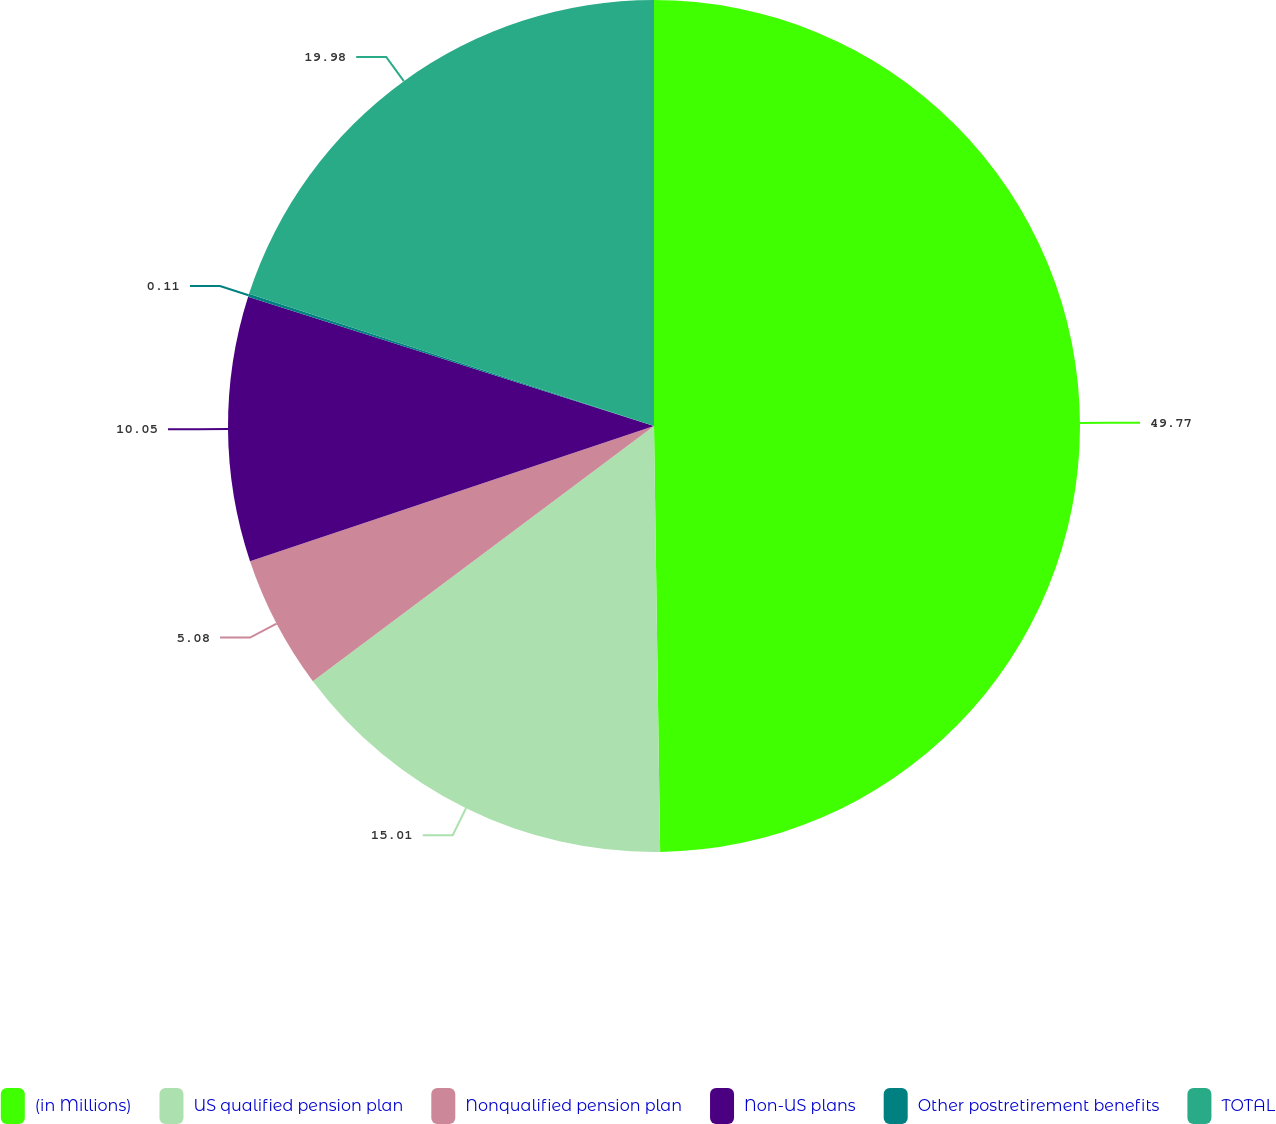<chart> <loc_0><loc_0><loc_500><loc_500><pie_chart><fcel>(in Millions)<fcel>US qualified pension plan<fcel>Nonqualified pension plan<fcel>Non-US plans<fcel>Other postretirement benefits<fcel>TOTAL<nl><fcel>49.77%<fcel>15.01%<fcel>5.08%<fcel>10.05%<fcel>0.11%<fcel>19.98%<nl></chart> 